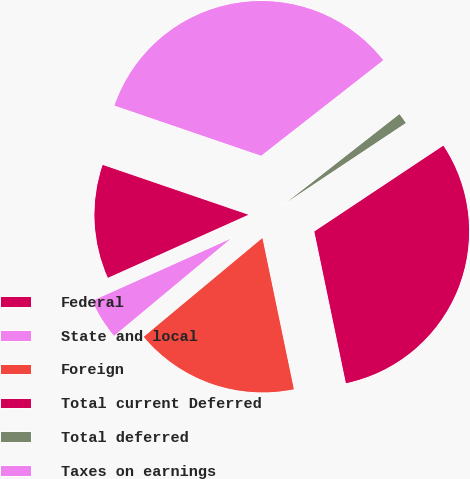Convert chart to OTSL. <chart><loc_0><loc_0><loc_500><loc_500><pie_chart><fcel>Federal<fcel>State and local<fcel>Foreign<fcel>Total current Deferred<fcel>Total deferred<fcel>Taxes on earnings<nl><fcel>11.96%<fcel>4.33%<fcel>17.22%<fcel>31.08%<fcel>1.22%<fcel>34.19%<nl></chart> 